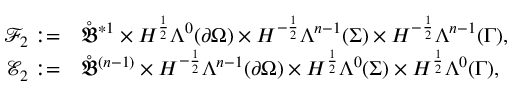Convert formula to latex. <formula><loc_0><loc_0><loc_500><loc_500>\begin{array} { r l } { \mathcal { F } _ { 2 } \colon = } & { \mathring { \mathfrak { B } } ^ { \ast 1 } \times H ^ { \frac { 1 } { 2 } } \Lambda ^ { 0 } ( \partial \Omega ) \times H ^ { - \frac { 1 } { 2 } } \Lambda ^ { n - 1 } ( \Sigma ) \times H ^ { - \frac { 1 } { 2 } } \Lambda ^ { n - 1 } ( \Gamma ) , } \\ { \mathcal { E } _ { 2 } \colon = } & { \mathring { \mathfrak { B } } ^ { ( n - 1 ) } \times H ^ { - \frac { 1 } { 2 } } \Lambda ^ { n - 1 } ( \partial \Omega ) \times H ^ { \frac { 1 } { 2 } } \Lambda ^ { 0 } ( \Sigma ) \times H ^ { \frac { 1 } { 2 } } \Lambda ^ { 0 } ( \Gamma ) , } \end{array}</formula> 